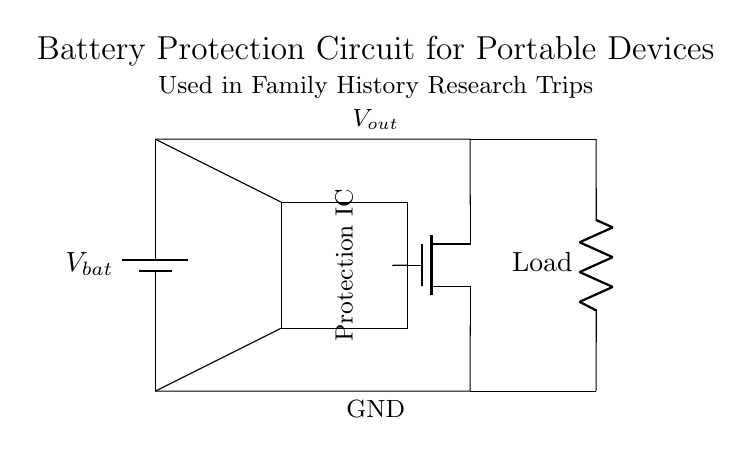What is the function of the Protection IC? The Protection IC manages safety aspects like overcurrent and overvoltage protection, ensuring that the circuit operates safely, particularly under variable load conditions.
Answer: Safety management What component limits the current flowing to the load? The MOSFET acts as a switch that controls current flow; it can turn on or off based on input signals from the Protection IC.
Answer: MOSFET How many outputs does the circuit have? The circuit has one output, indicated by the connection labeled Vout, which supplies power to the load.
Answer: One What is the voltage of the battery in this circuit? The circuit shows a battery labeled Vbat, but the exact voltage is not specified. It represents the supply voltage to the circuit.
Answer: Vbat What type of load is included in the circuit? The load is indicated as a resistor in the schematic, representing the device or component powered by the battery protection circuit.
Answer: Resistor How does the Protection IC receive its power? The Protection IC is connected to the battery via a direct connection, allowing it to operate while preserving its protective functions for the load.
Answer: From the battery What role does the MOSFET play in this circuit? The MOSFET acts as a switch controlled by signals from the Protection IC, allowing or interrupting current flow based on the safety criteria set by the IC.
Answer: Switch 